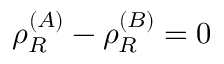Convert formula to latex. <formula><loc_0><loc_0><loc_500><loc_500>\rho _ { R } ^ { ( A ) } - \rho _ { R } ^ { ( B ) } = 0</formula> 